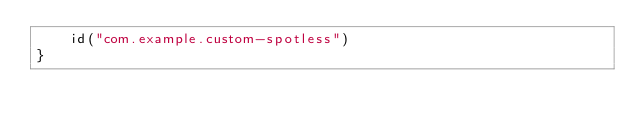<code> <loc_0><loc_0><loc_500><loc_500><_Kotlin_>    id("com.example.custom-spotless")
}</code> 